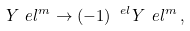<formula> <loc_0><loc_0><loc_500><loc_500>Y _ { \ } e l ^ { m } \rightarrow ( - 1 ) ^ { \ e l } Y _ { \ } e l ^ { m } \, ,</formula> 